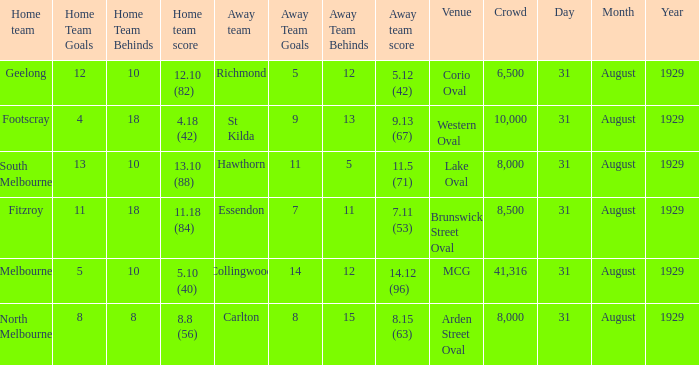What was the score of the home team when the away team scored 14.12 (96)? 5.10 (40). 